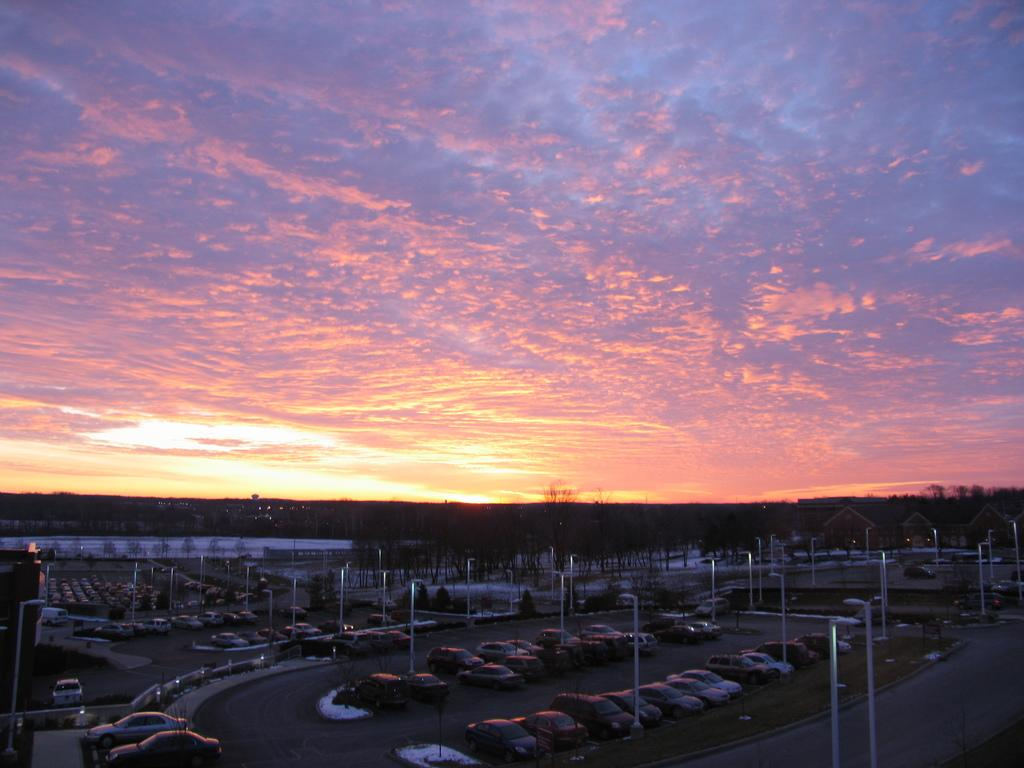What can be seen at the bottom of the image? At the bottom of the image, there are poles, trees, vehicles, buildings, and roads. What is visible in the background of the image? The sky is visible in the background of the image. What can be observed in the sky? Clouds are present in the sky. Where is the sheet hanging in the image? There is no sheet present in the image. What type of cave can be seen in the image? There is no cave present in the image. 